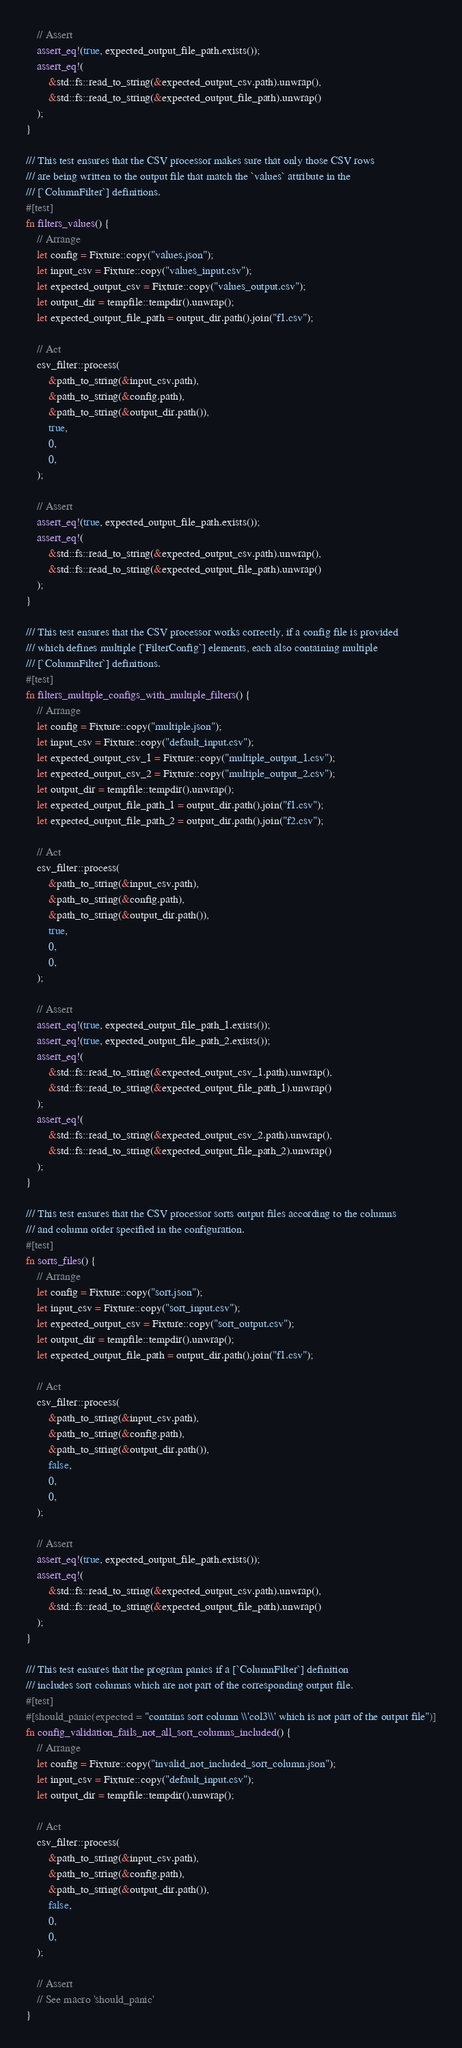<code> <loc_0><loc_0><loc_500><loc_500><_Rust_>
    // Assert
    assert_eq!(true, expected_output_file_path.exists());
    assert_eq!(
        &std::fs::read_to_string(&expected_output_csv.path).unwrap(),
        &std::fs::read_to_string(&expected_output_file_path).unwrap()
    );
}

/// This test ensures that the CSV processor makes sure that only those CSV rows
/// are being written to the output file that match the `values` attribute in the
/// [`ColumnFilter`] definitions.
#[test]
fn filters_values() {
    // Arrange
    let config = Fixture::copy("values.json");
    let input_csv = Fixture::copy("values_input.csv");
    let expected_output_csv = Fixture::copy("values_output.csv");
    let output_dir = tempfile::tempdir().unwrap();
    let expected_output_file_path = output_dir.path().join("f1.csv");

    // Act
    csv_filter::process(
        &path_to_string(&input_csv.path),
        &path_to_string(&config.path),
        &path_to_string(&output_dir.path()),
        true,
        0,
        0,
    );

    // Assert
    assert_eq!(true, expected_output_file_path.exists());
    assert_eq!(
        &std::fs::read_to_string(&expected_output_csv.path).unwrap(),
        &std::fs::read_to_string(&expected_output_file_path).unwrap()
    );
}

/// This test ensures that the CSV processor works correctly, if a config file is provided
/// which defines multiple [`FilterConfig`] elements, each also containing multiple
/// [`ColumnFilter`] definitions.
#[test]
fn filters_multiple_configs_with_multiple_filters() {
    // Arrange
    let config = Fixture::copy("multiple.json");
    let input_csv = Fixture::copy("default_input.csv");
    let expected_output_csv_1 = Fixture::copy("multiple_output_1.csv");
    let expected_output_csv_2 = Fixture::copy("multiple_output_2.csv");
    let output_dir = tempfile::tempdir().unwrap();
    let expected_output_file_path_1 = output_dir.path().join("f1.csv");
    let expected_output_file_path_2 = output_dir.path().join("f2.csv");

    // Act
    csv_filter::process(
        &path_to_string(&input_csv.path),
        &path_to_string(&config.path),
        &path_to_string(&output_dir.path()),
        true,
        0,
        0,
    );

    // Assert
    assert_eq!(true, expected_output_file_path_1.exists());
    assert_eq!(true, expected_output_file_path_2.exists());
    assert_eq!(
        &std::fs::read_to_string(&expected_output_csv_1.path).unwrap(),
        &std::fs::read_to_string(&expected_output_file_path_1).unwrap()
    );
    assert_eq!(
        &std::fs::read_to_string(&expected_output_csv_2.path).unwrap(),
        &std::fs::read_to_string(&expected_output_file_path_2).unwrap()
    );
}

/// This test ensures that the CSV processor sorts output files according to the columns
/// and column order specified in the configuration.
#[test]
fn sorts_files() {
    // Arrange
    let config = Fixture::copy("sort.json");
    let input_csv = Fixture::copy("sort_input.csv");
    let expected_output_csv = Fixture::copy("sort_output.csv");
    let output_dir = tempfile::tempdir().unwrap();
    let expected_output_file_path = output_dir.path().join("f1.csv");

    // Act
    csv_filter::process(
        &path_to_string(&input_csv.path),
        &path_to_string(&config.path),
        &path_to_string(&output_dir.path()),
        false,
        0,
        0,
    );

    // Assert
    assert_eq!(true, expected_output_file_path.exists());
    assert_eq!(
        &std::fs::read_to_string(&expected_output_csv.path).unwrap(),
        &std::fs::read_to_string(&expected_output_file_path).unwrap()
    );
}

/// This test ensures that the program panics if a [`ColumnFilter`] definition
/// includes sort columns which are not part of the corresponding output file.
#[test]
#[should_panic(expected = "contains sort column \\'col3\\' which is not part of the output file")]
fn config_validation_fails_not_all_sort_columns_included() {
    // Arrange
    let config = Fixture::copy("invalid_not_included_sort_column.json");
    let input_csv = Fixture::copy("default_input.csv");
    let output_dir = tempfile::tempdir().unwrap();

    // Act
    csv_filter::process(
        &path_to_string(&input_csv.path),
        &path_to_string(&config.path),
        &path_to_string(&output_dir.path()),
        false,
        0,
        0,
    );

    // Assert
    // See macro 'should_panic'
}
</code> 